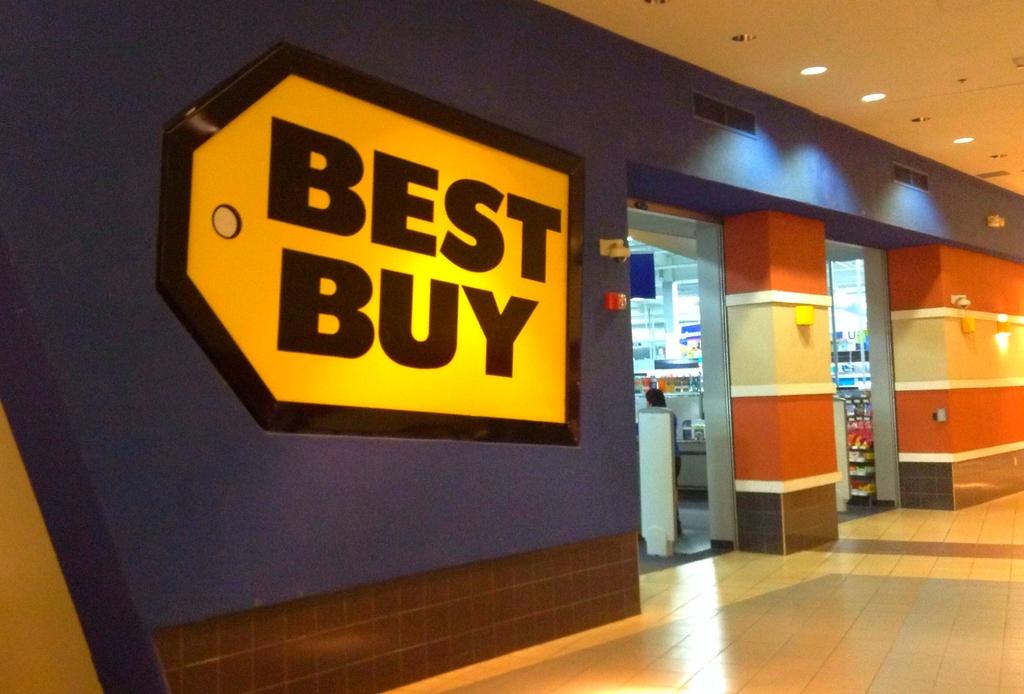What store is this?
Your answer should be compact. Best buy. 